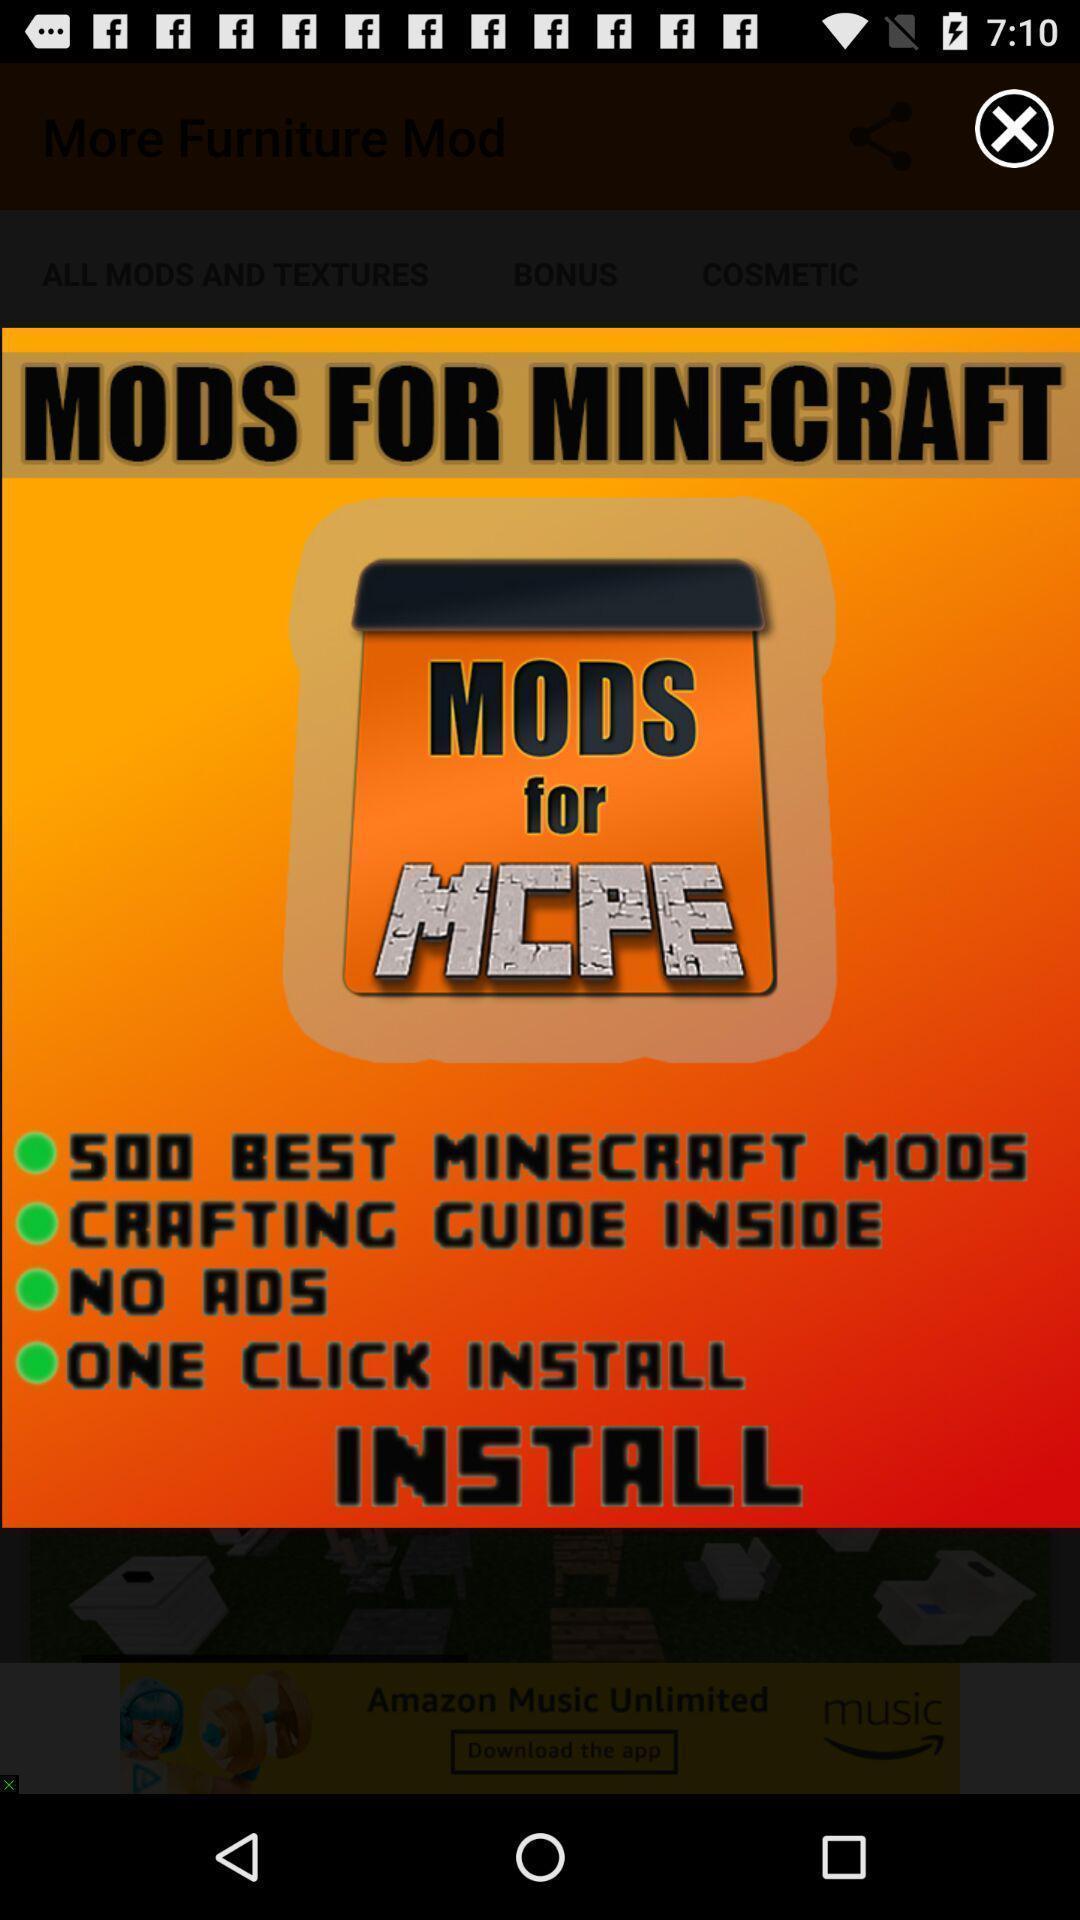Please provide a description for this image. Pop up showing click to install application. 